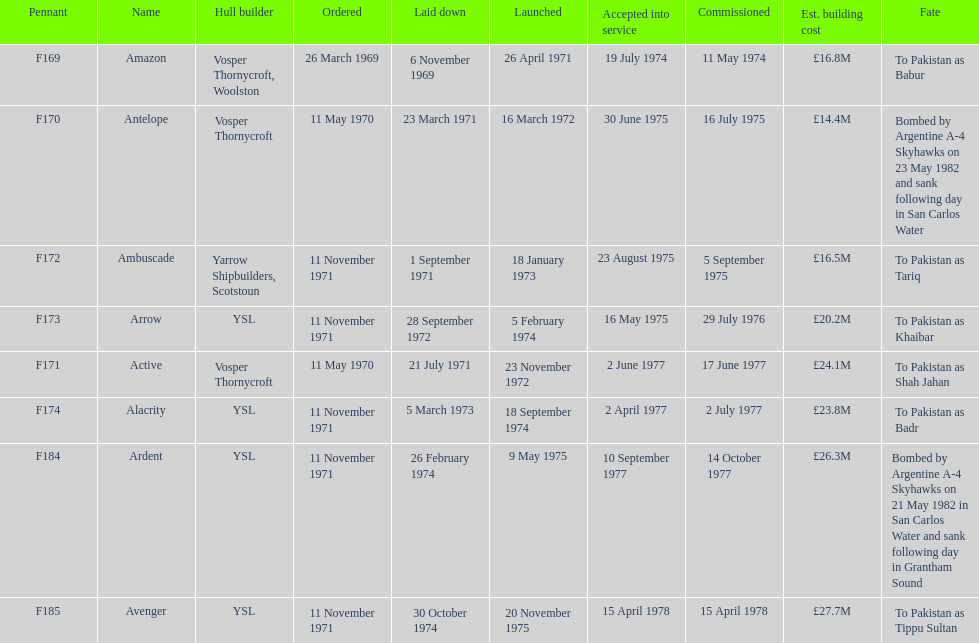How many boats costed less than £20m to build? 3. 